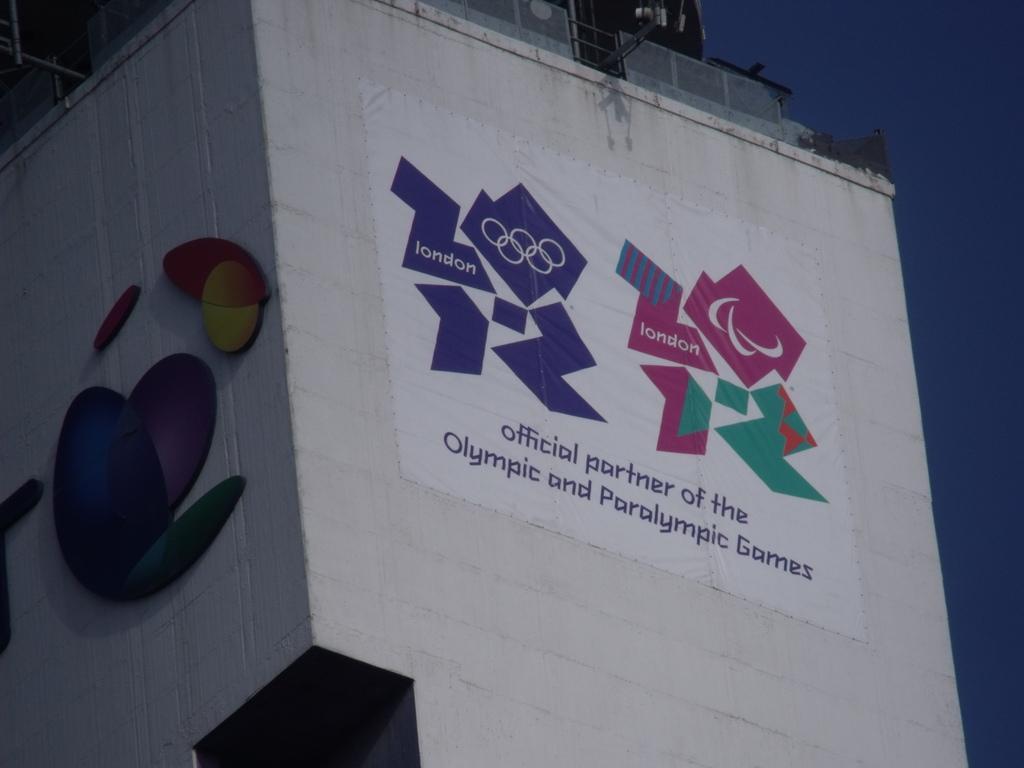How would you summarize this image in a sentence or two? In the image there is a building and there is some banner attached to that building. 